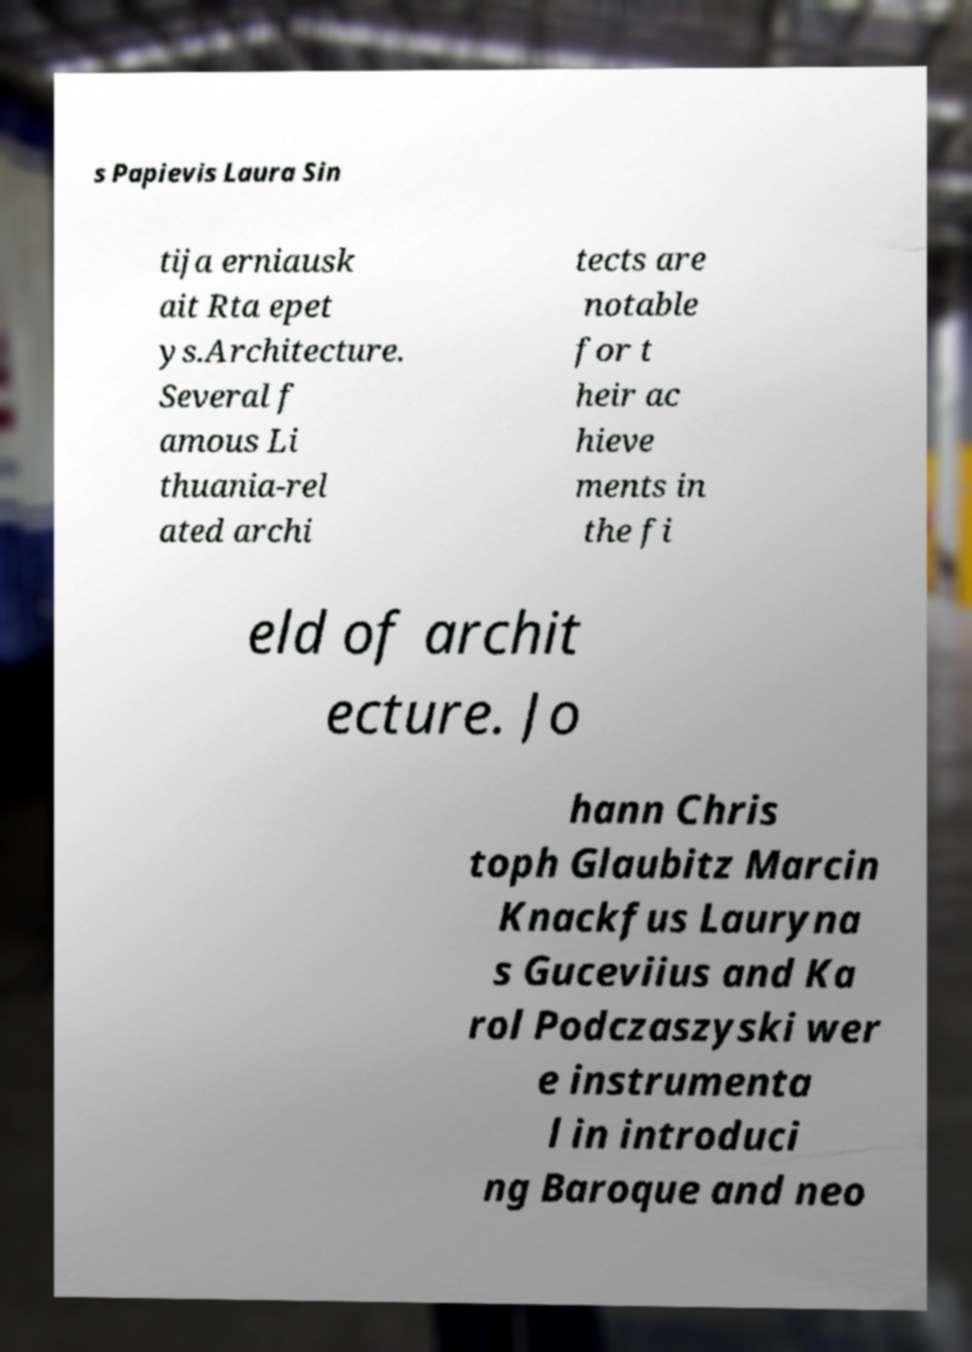Can you read and provide the text displayed in the image?This photo seems to have some interesting text. Can you extract and type it out for me? s Papievis Laura Sin tija erniausk ait Rta epet ys.Architecture. Several f amous Li thuania-rel ated archi tects are notable for t heir ac hieve ments in the fi eld of archit ecture. Jo hann Chris toph Glaubitz Marcin Knackfus Lauryna s Guceviius and Ka rol Podczaszyski wer e instrumenta l in introduci ng Baroque and neo 